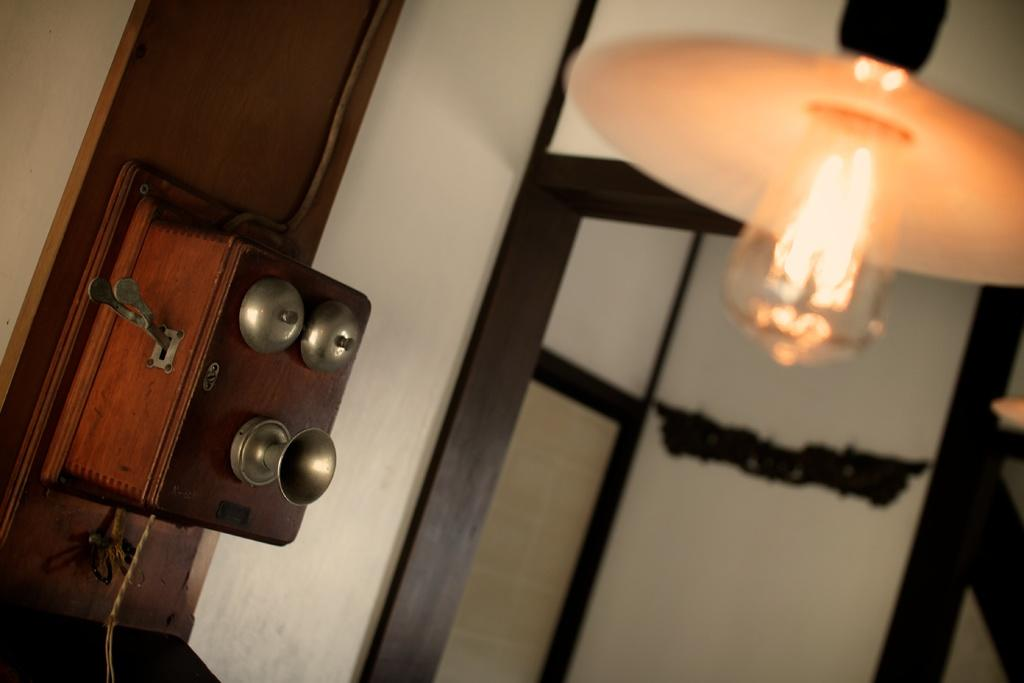What is the main object in the image that provides light? There is a lamp with a bulb in the image. What is the background of the image? There is a wall in the image. What is the object in the image that has a box attached to it? There is a box in the image that is attached to bells. What color are the eyes of the person wearing jeans in the image? There is no person wearing jeans in the image, and therefore no eyes to describe. 